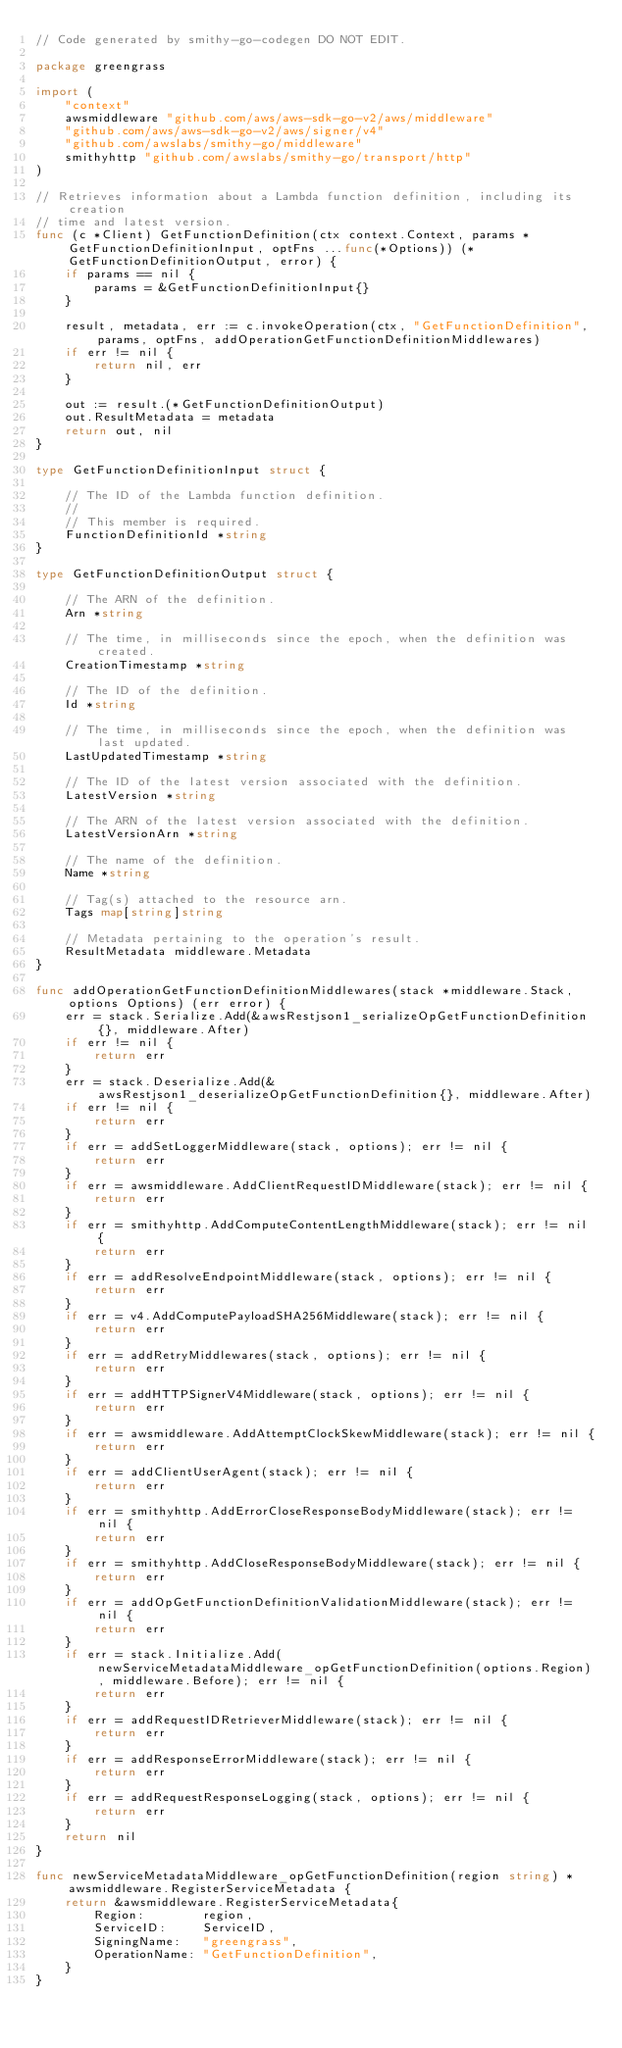<code> <loc_0><loc_0><loc_500><loc_500><_Go_>// Code generated by smithy-go-codegen DO NOT EDIT.

package greengrass

import (
	"context"
	awsmiddleware "github.com/aws/aws-sdk-go-v2/aws/middleware"
	"github.com/aws/aws-sdk-go-v2/aws/signer/v4"
	"github.com/awslabs/smithy-go/middleware"
	smithyhttp "github.com/awslabs/smithy-go/transport/http"
)

// Retrieves information about a Lambda function definition, including its creation
// time and latest version.
func (c *Client) GetFunctionDefinition(ctx context.Context, params *GetFunctionDefinitionInput, optFns ...func(*Options)) (*GetFunctionDefinitionOutput, error) {
	if params == nil {
		params = &GetFunctionDefinitionInput{}
	}

	result, metadata, err := c.invokeOperation(ctx, "GetFunctionDefinition", params, optFns, addOperationGetFunctionDefinitionMiddlewares)
	if err != nil {
		return nil, err
	}

	out := result.(*GetFunctionDefinitionOutput)
	out.ResultMetadata = metadata
	return out, nil
}

type GetFunctionDefinitionInput struct {

	// The ID of the Lambda function definition.
	//
	// This member is required.
	FunctionDefinitionId *string
}

type GetFunctionDefinitionOutput struct {

	// The ARN of the definition.
	Arn *string

	// The time, in milliseconds since the epoch, when the definition was created.
	CreationTimestamp *string

	// The ID of the definition.
	Id *string

	// The time, in milliseconds since the epoch, when the definition was last updated.
	LastUpdatedTimestamp *string

	// The ID of the latest version associated with the definition.
	LatestVersion *string

	// The ARN of the latest version associated with the definition.
	LatestVersionArn *string

	// The name of the definition.
	Name *string

	// Tag(s) attached to the resource arn.
	Tags map[string]string

	// Metadata pertaining to the operation's result.
	ResultMetadata middleware.Metadata
}

func addOperationGetFunctionDefinitionMiddlewares(stack *middleware.Stack, options Options) (err error) {
	err = stack.Serialize.Add(&awsRestjson1_serializeOpGetFunctionDefinition{}, middleware.After)
	if err != nil {
		return err
	}
	err = stack.Deserialize.Add(&awsRestjson1_deserializeOpGetFunctionDefinition{}, middleware.After)
	if err != nil {
		return err
	}
	if err = addSetLoggerMiddleware(stack, options); err != nil {
		return err
	}
	if err = awsmiddleware.AddClientRequestIDMiddleware(stack); err != nil {
		return err
	}
	if err = smithyhttp.AddComputeContentLengthMiddleware(stack); err != nil {
		return err
	}
	if err = addResolveEndpointMiddleware(stack, options); err != nil {
		return err
	}
	if err = v4.AddComputePayloadSHA256Middleware(stack); err != nil {
		return err
	}
	if err = addRetryMiddlewares(stack, options); err != nil {
		return err
	}
	if err = addHTTPSignerV4Middleware(stack, options); err != nil {
		return err
	}
	if err = awsmiddleware.AddAttemptClockSkewMiddleware(stack); err != nil {
		return err
	}
	if err = addClientUserAgent(stack); err != nil {
		return err
	}
	if err = smithyhttp.AddErrorCloseResponseBodyMiddleware(stack); err != nil {
		return err
	}
	if err = smithyhttp.AddCloseResponseBodyMiddleware(stack); err != nil {
		return err
	}
	if err = addOpGetFunctionDefinitionValidationMiddleware(stack); err != nil {
		return err
	}
	if err = stack.Initialize.Add(newServiceMetadataMiddleware_opGetFunctionDefinition(options.Region), middleware.Before); err != nil {
		return err
	}
	if err = addRequestIDRetrieverMiddleware(stack); err != nil {
		return err
	}
	if err = addResponseErrorMiddleware(stack); err != nil {
		return err
	}
	if err = addRequestResponseLogging(stack, options); err != nil {
		return err
	}
	return nil
}

func newServiceMetadataMiddleware_opGetFunctionDefinition(region string) *awsmiddleware.RegisterServiceMetadata {
	return &awsmiddleware.RegisterServiceMetadata{
		Region:        region,
		ServiceID:     ServiceID,
		SigningName:   "greengrass",
		OperationName: "GetFunctionDefinition",
	}
}
</code> 